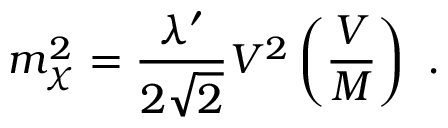<formula> <loc_0><loc_0><loc_500><loc_500>m _ { \chi } ^ { 2 } = \frac { \lambda ^ { \prime } } { 2 \sqrt { 2 } } V ^ { 2 } \left ( \frac { V } { M } \right ) .</formula> 